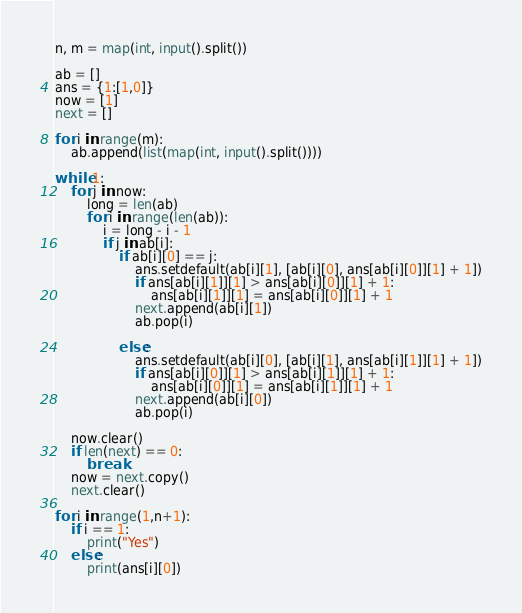<code> <loc_0><loc_0><loc_500><loc_500><_Python_>n, m = map(int, input().split())

ab = []
ans = {1:[1,0]}
now = [1]
next = []

for i in range(m):
    ab.append(list(map(int, input().split())))

while 1:
    for j in now:
        long = len(ab)
        for i in range(len(ab)):
            i = long - i - 1
            if j in ab[i]:
                if ab[i][0] == j:
                    ans.setdefault(ab[i][1], [ab[i][0], ans[ab[i][0]][1] + 1])
                    if ans[ab[i][1]][1] > ans[ab[i][0]][1] + 1:
                        ans[ab[i][1]][1] = ans[ab[i][0]][1] + 1
                    next.append(ab[i][1])
                    ab.pop(i)

                else:
                    ans.setdefault(ab[i][0], [ab[i][1], ans[ab[i][1]][1] + 1])
                    if ans[ab[i][0]][1] > ans[ab[i][1]][1] + 1:
                        ans[ab[i][0]][1] = ans[ab[i][1]][1] + 1
                    next.append(ab[i][0])
                    ab.pop(i)

    now.clear()
    if len(next) == 0:
        break
    now = next.copy()
    next.clear()

for i in range(1,n+1):
    if i == 1:
        print("Yes")
    else:
        print(ans[i][0])</code> 